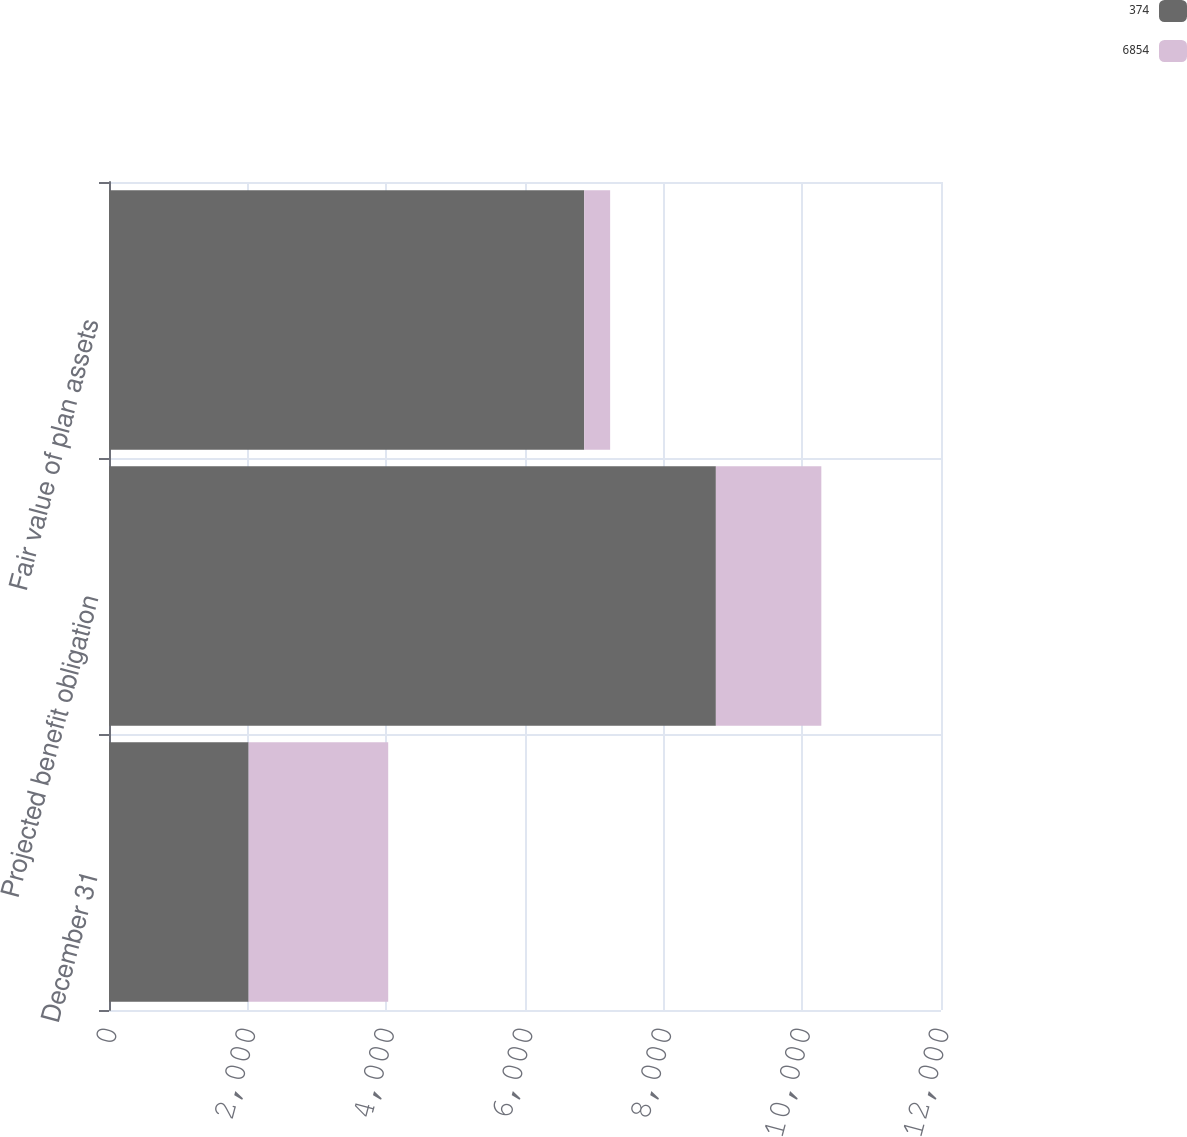Convert chart. <chart><loc_0><loc_0><loc_500><loc_500><stacked_bar_chart><ecel><fcel>December 31<fcel>Projected benefit obligation<fcel>Fair value of plan assets<nl><fcel>374<fcel>2014<fcel>8753<fcel>6854<nl><fcel>6854<fcel>2013<fcel>1521<fcel>374<nl></chart> 